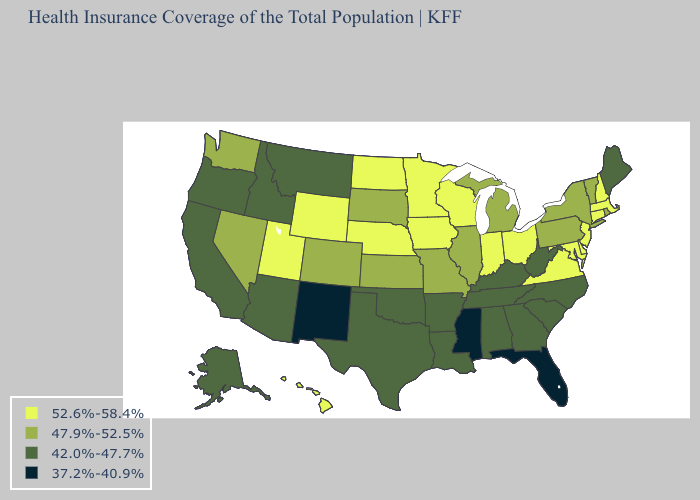What is the value of Michigan?
Give a very brief answer. 47.9%-52.5%. What is the lowest value in the USA?
Write a very short answer. 37.2%-40.9%. What is the value of Rhode Island?
Concise answer only. 47.9%-52.5%. What is the value of Nebraska?
Concise answer only. 52.6%-58.4%. What is the value of Delaware?
Be succinct. 52.6%-58.4%. Name the states that have a value in the range 42.0%-47.7%?
Short answer required. Alabama, Alaska, Arizona, Arkansas, California, Georgia, Idaho, Kentucky, Louisiana, Maine, Montana, North Carolina, Oklahoma, Oregon, South Carolina, Tennessee, Texas, West Virginia. What is the value of New York?
Concise answer only. 47.9%-52.5%. What is the value of Idaho?
Short answer required. 42.0%-47.7%. Name the states that have a value in the range 52.6%-58.4%?
Give a very brief answer. Connecticut, Delaware, Hawaii, Indiana, Iowa, Maryland, Massachusetts, Minnesota, Nebraska, New Hampshire, New Jersey, North Dakota, Ohio, Utah, Virginia, Wisconsin, Wyoming. Which states have the lowest value in the USA?
Quick response, please. Florida, Mississippi, New Mexico. Among the states that border New Hampshire , does Maine have the lowest value?
Short answer required. Yes. What is the highest value in the MidWest ?
Answer briefly. 52.6%-58.4%. Name the states that have a value in the range 42.0%-47.7%?
Give a very brief answer. Alabama, Alaska, Arizona, Arkansas, California, Georgia, Idaho, Kentucky, Louisiana, Maine, Montana, North Carolina, Oklahoma, Oregon, South Carolina, Tennessee, Texas, West Virginia. What is the value of Illinois?
Keep it brief. 47.9%-52.5%. 